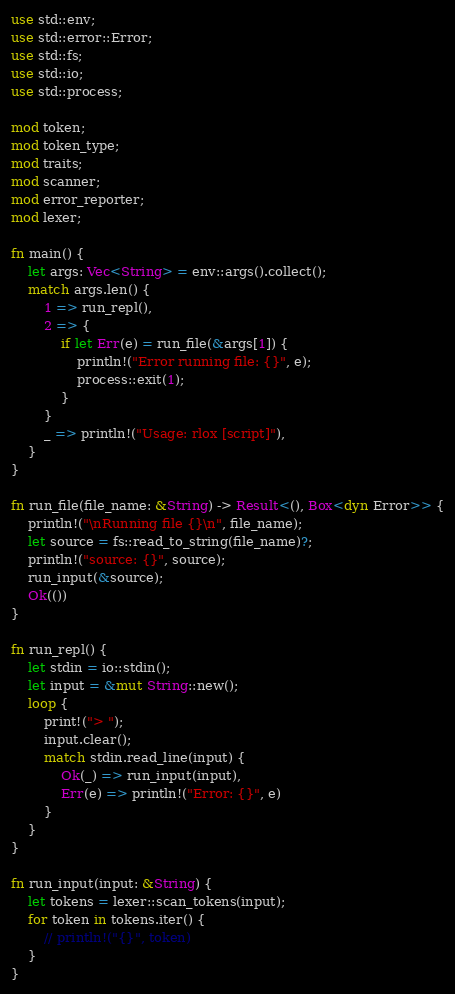<code> <loc_0><loc_0><loc_500><loc_500><_Rust_>use std::env;
use std::error::Error;
use std::fs;
use std::io;
use std::process;

mod token;
mod token_type;
mod traits;
mod scanner;
mod error_reporter;
mod lexer;

fn main() {
    let args: Vec<String> = env::args().collect();
    match args.len() {
        1 => run_repl(),
        2 => {
            if let Err(e) = run_file(&args[1]) {
                println!("Error running file: {}", e);
                process::exit(1);
            }
        }
        _ => println!("Usage: rlox [script]"),
    }
}

fn run_file(file_name: &String) -> Result<(), Box<dyn Error>> {
    println!("\nRunning file {}\n", file_name);
    let source = fs::read_to_string(file_name)?;
    println!("source: {}", source);
    run_input(&source);
    Ok(())
}

fn run_repl() {
    let stdin = io::stdin();
    let input = &mut String::new();
    loop {
        print!("> ");
        input.clear();
        match stdin.read_line(input) {
            Ok(_) => run_input(input),
            Err(e) => println!("Error: {}", e)
        }
    }
}

fn run_input(input: &String) {
    let tokens = lexer::scan_tokens(input);
    for token in tokens.iter() {
        // println!("{}", token)
    }
}
</code> 